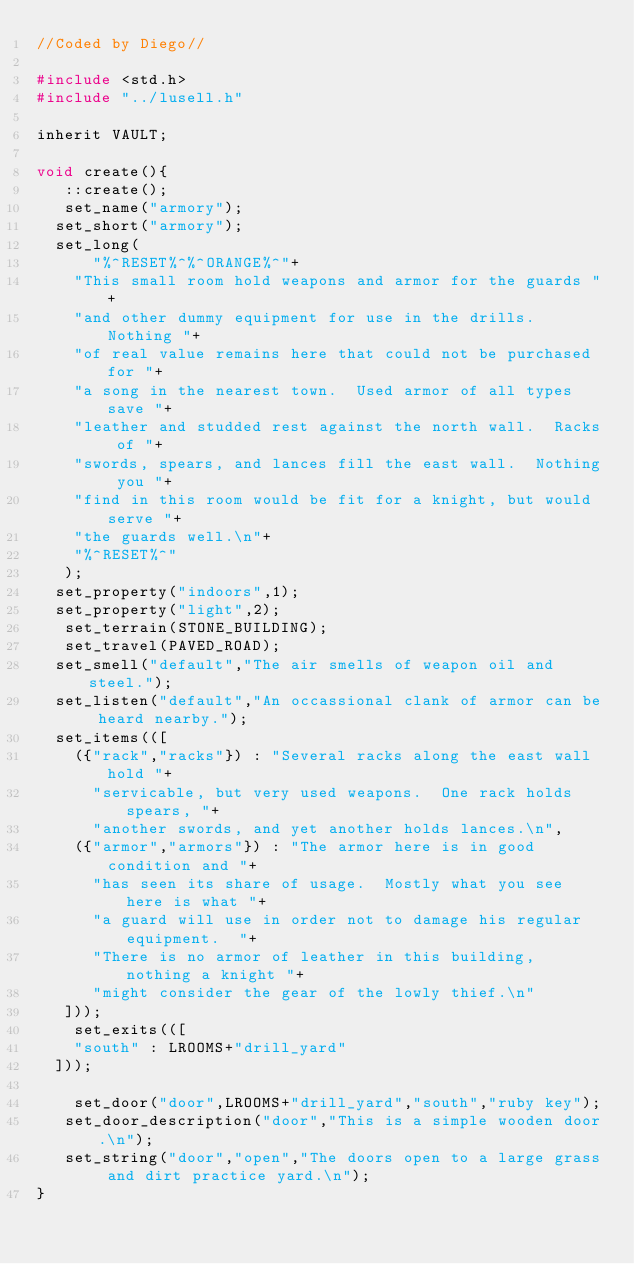Convert code to text. <code><loc_0><loc_0><loc_500><loc_500><_C_>//Coded by Diego//

#include <std.h>
#include "../lusell.h"

inherit VAULT;

void create(){
   ::create();
   set_name("armory");
	set_short("armory");
	set_long(
    	"%^RESET%^%^ORANGE%^"+
		"This small room hold weapons and armor for the guards "+
		"and other dummy equipment for use in the drills.  Nothing "+
		"of real value remains here that could not be purchased for "+
		"a song in the nearest town.  Used armor of all types save "+
		"leather and studded rest against the north wall.  Racks of "+
		"swords, spears, and lances fill the east wall.  Nothing you "+
		"find in this room would be fit for a knight, but would serve "+
		"the guards well.\n"+
		"%^RESET%^"
   );
	set_property("indoors",1);
	set_property("light",2);
   set_terrain(STONE_BUILDING);
   set_travel(PAVED_ROAD);
	set_smell("default","The air smells of weapon oil and steel.");
	set_listen("default","An occassional clank of armor can be heard nearby.");
	set_items(([
		({"rack","racks"}) : "Several racks along the east wall hold "+
			"servicable, but very used weapons.  One rack holds spears, "+
			"another swords, and yet another holds lances.\n",
		({"armor","armors"}) : "The armor here is in good condition and "+
			"has seen its share of usage.  Mostly what you see here is what "+
			"a guard will use in order not to damage his regular equipment.  "+
			"There is no armor of leather in this building, nothing a knight "+
			"might consider the gear of the lowly thief.\n"
   ]));
  	set_exits(([
		"south" : LROOMS+"drill_yard"
	]));

  	set_door("door",LROOMS+"drill_yard","south","ruby key");
   set_door_description("door","This is a simple wooden door.\n");
   set_string("door","open","The doors open to a large grass and dirt practice yard.\n");
}
</code> 